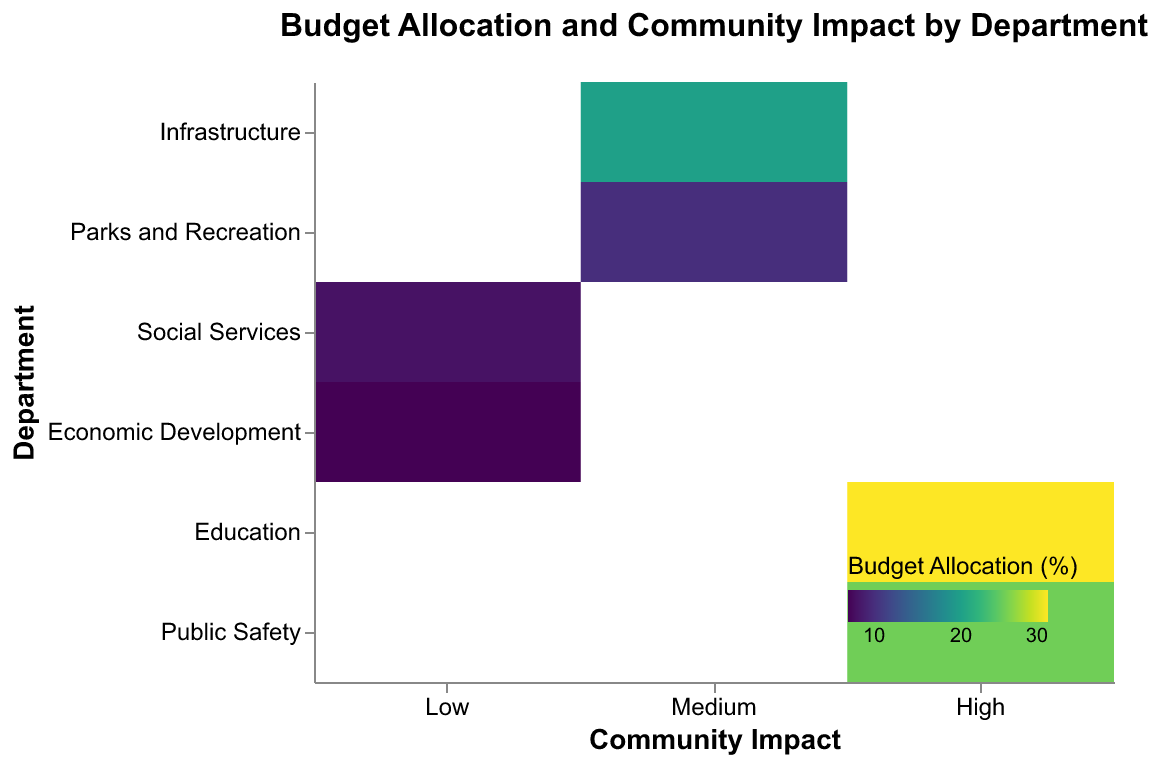What is the title of the plot? To identify the title, look at the top of the plot where the main text summarizing the chart's content is displayed.
Answer: Budget Allocation and Community Impact by Department Which department has the highest budget allocation? Find the rectangles within the plot and look for the one with the darkest shade, representing the highest budget allocation percentage. Notice the associated department on the y-axis.
Answer: Education What are the two departments with 'High' community impact? Look at the x-axis values labeled 'High' and identify the departments aligned with these values.
Answer: Education, Public Safety How does the budget allocation for 'Infrastructure' compare to 'Parks and Recreation'? Identify the rectangles corresponding to 'Infrastructure' and 'Parks and Recreation' and compare their shades. 'Infrastructure' is higher because its rectangle is darker.
Answer: Infrastructure has a higher budget allocation Which departments fall under the 'Low' community impact category? Look at the x-axis values labeled 'Low' and identify the departments aligned with these values.
Answer: Social Services, Economic Development How many departments have a 'Medium' community impact? Count the number of rectangles aligning with 'Medium' on the x-axis.
Answer: 2 What is the combined budget allocation percentage for departments with 'Medium' community impact? Identify the departments under 'Medium' impact (Infrastructure and Parks and Recreation), and sum their budget allocation percentages: 20+10.
Answer: 30% Which department has the lowest budget allocation and what is its community impact? Look for the department with the lightest shaded rectangle, representing the lowest budget allocation. Observe its aligned community impact value on the x-axis.
Answer: Economic Development, Low How much more budget does 'Education' receive compared to 'Social Services'? Identify the budget allocation percentages for 'Education' (30%) and 'Social Services' (8%), then compute the difference: 30 - 8.
Answer: 22% Which two impact categories have only one department each? Look at the x-axis and identify the categories with only one rectangle (unique alignment for a department). 'Low' and 'Medium' categories are verified; however, all have multiple departments.
Answer: None 